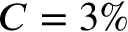<formula> <loc_0><loc_0><loc_500><loc_500>C = 3 \%</formula> 